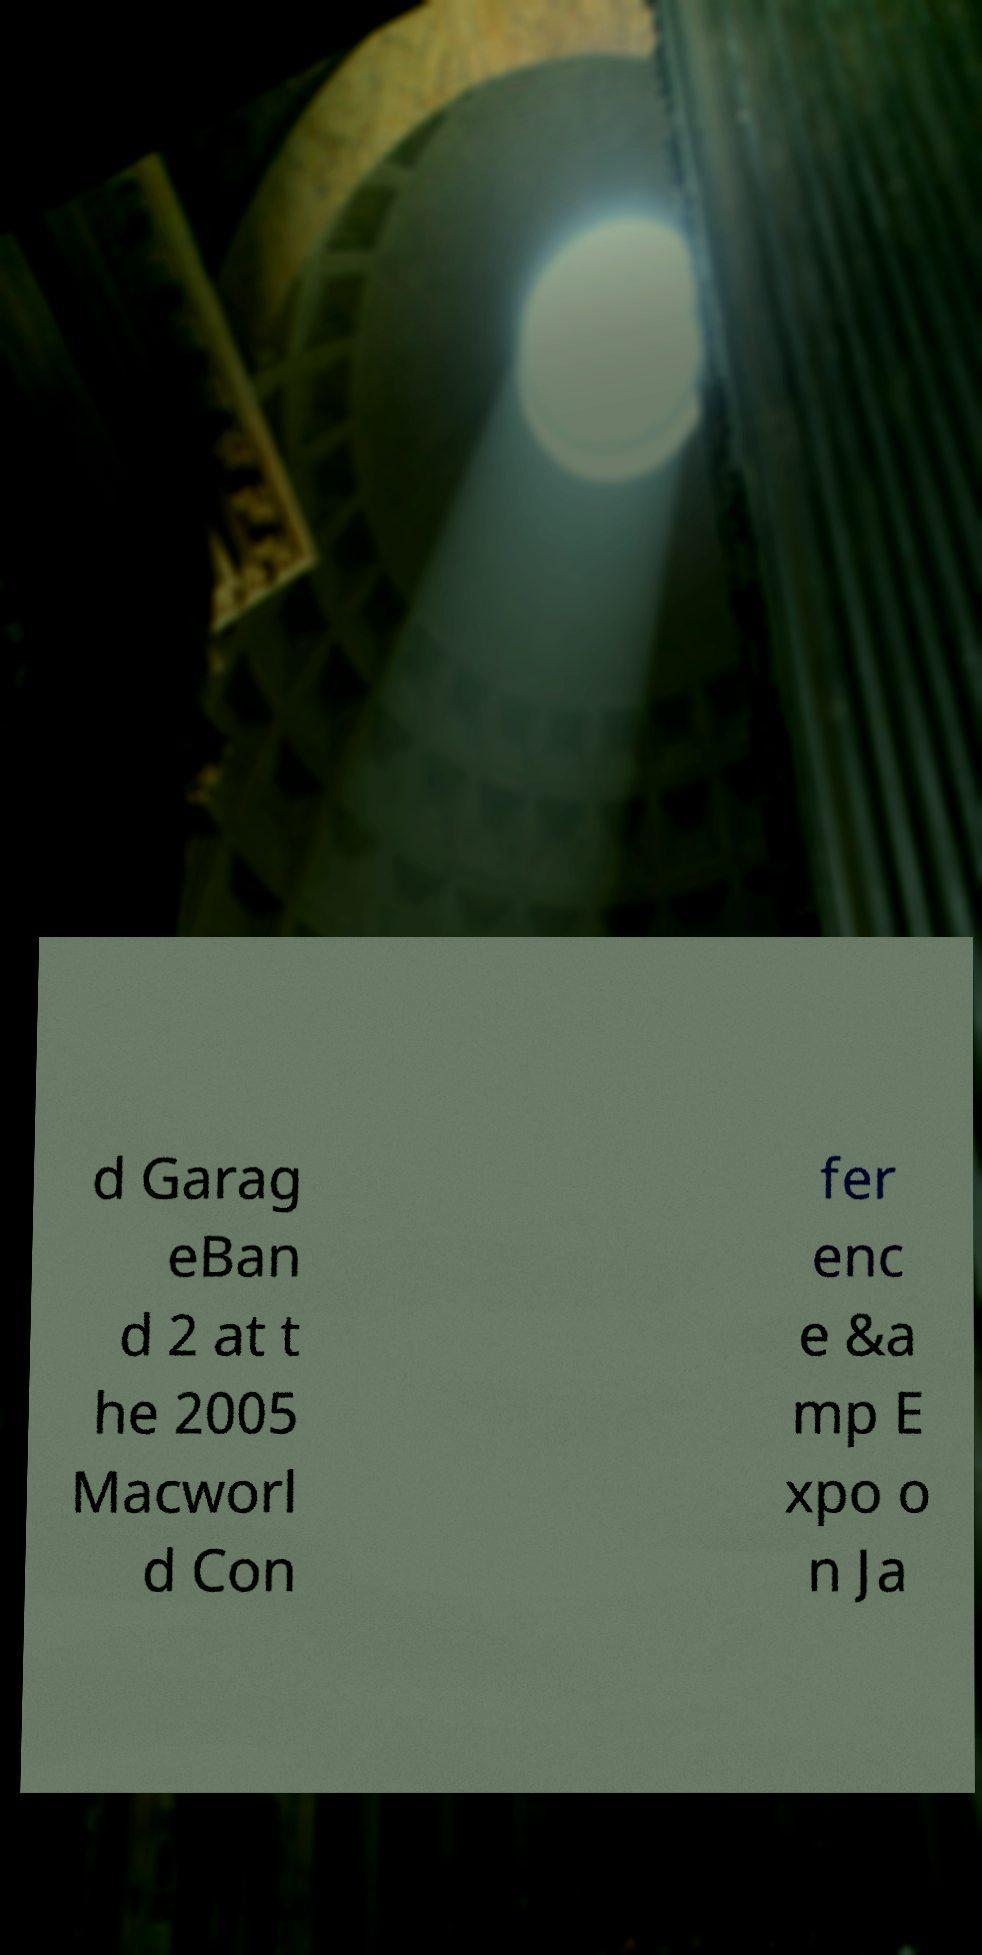For documentation purposes, I need the text within this image transcribed. Could you provide that? d Garag eBan d 2 at t he 2005 Macworl d Con fer enc e &a mp E xpo o n Ja 